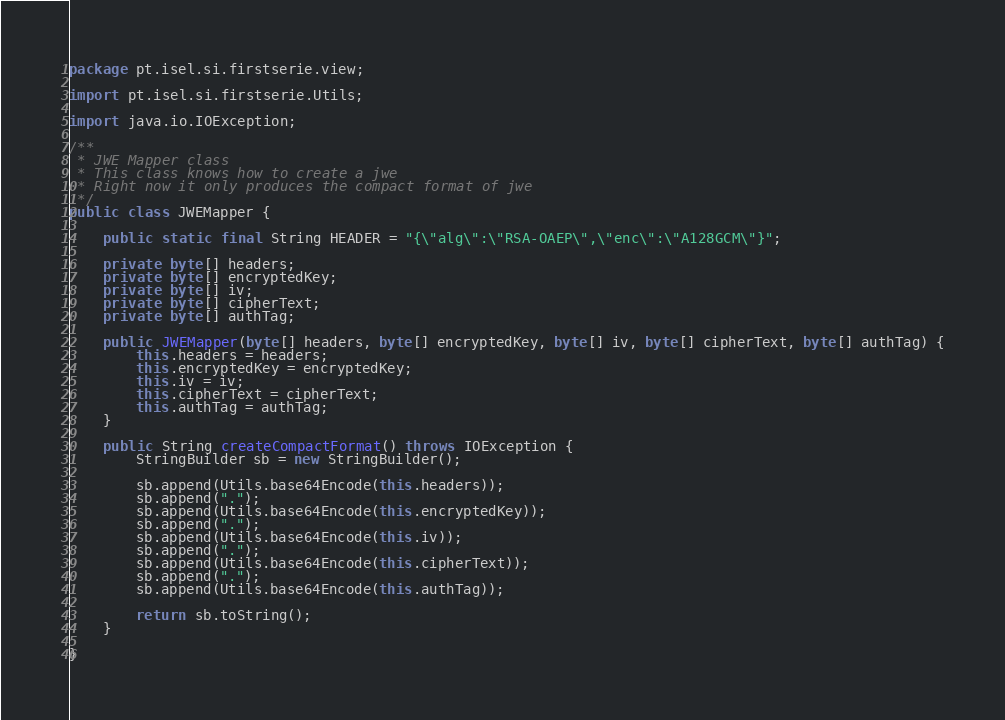Convert code to text. <code><loc_0><loc_0><loc_500><loc_500><_Java_>package pt.isel.si.firstserie.view;

import pt.isel.si.firstserie.Utils;

import java.io.IOException;

/**
 * JWE Mapper class
 * This class knows how to create a jwe
 * Right now it only produces the compact format of jwe
 */
public class JWEMapper {

    public static final String HEADER = "{\"alg\":\"RSA-OAEP\",\"enc\":\"A128GCM\"}";

    private byte[] headers;
    private byte[] encryptedKey;
    private byte[] iv;
    private byte[] cipherText;
    private byte[] authTag;

    public JWEMapper(byte[] headers, byte[] encryptedKey, byte[] iv, byte[] cipherText, byte[] authTag) {
        this.headers = headers;
        this.encryptedKey = encryptedKey;
        this.iv = iv;
        this.cipherText = cipherText;
        this.authTag = authTag;
    }

    public String createCompactFormat() throws IOException {
        StringBuilder sb = new StringBuilder();

        sb.append(Utils.base64Encode(this.headers));
        sb.append(".");
        sb.append(Utils.base64Encode(this.encryptedKey));
        sb.append(".");
        sb.append(Utils.base64Encode(this.iv));
        sb.append(".");
        sb.append(Utils.base64Encode(this.cipherText));
        sb.append(".");
        sb.append(Utils.base64Encode(this.authTag));

        return sb.toString();
    }

}
</code> 